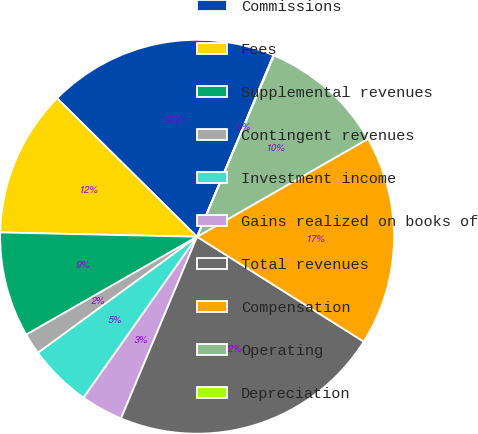Convert chart to OTSL. <chart><loc_0><loc_0><loc_500><loc_500><pie_chart><fcel>Commissions<fcel>Fees<fcel>Supplemental revenues<fcel>Contingent revenues<fcel>Investment income<fcel>Gains realized on books of<fcel>Total revenues<fcel>Compensation<fcel>Operating<fcel>Depreciation<nl><fcel>18.93%<fcel>12.06%<fcel>8.63%<fcel>1.75%<fcel>5.19%<fcel>3.47%<fcel>22.37%<fcel>17.22%<fcel>10.34%<fcel>0.04%<nl></chart> 